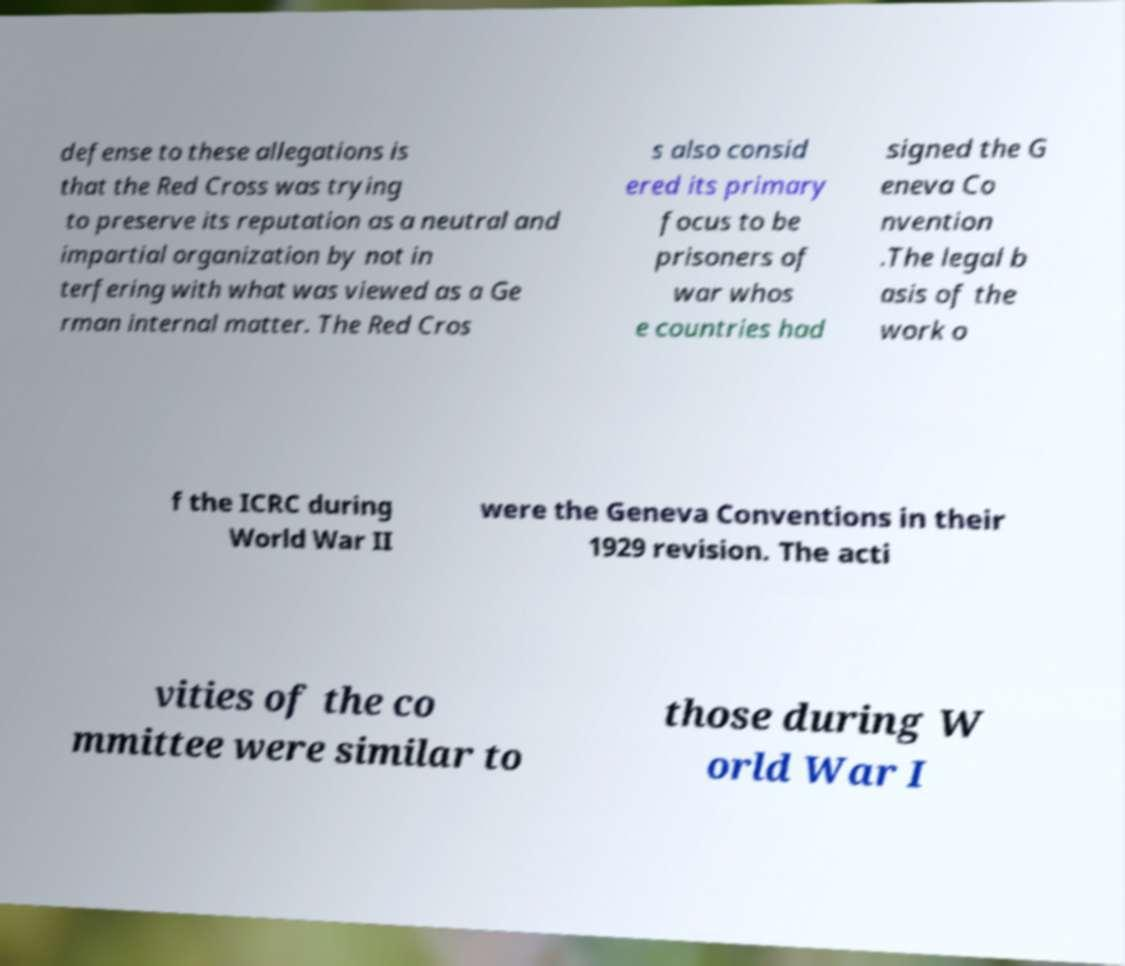There's text embedded in this image that I need extracted. Can you transcribe it verbatim? defense to these allegations is that the Red Cross was trying to preserve its reputation as a neutral and impartial organization by not in terfering with what was viewed as a Ge rman internal matter. The Red Cros s also consid ered its primary focus to be prisoners of war whos e countries had signed the G eneva Co nvention .The legal b asis of the work o f the ICRC during World War II were the Geneva Conventions in their 1929 revision. The acti vities of the co mmittee were similar to those during W orld War I 